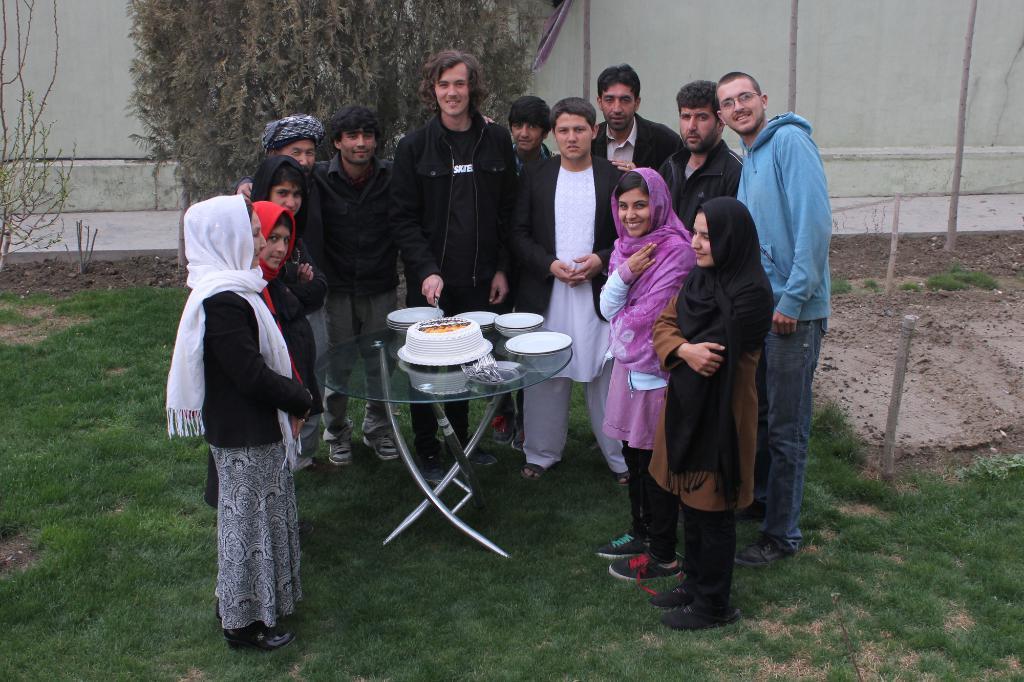How would you summarize this image in a sentence or two? These persons are standing. We can see cake,plates on the table. On the background we can see wall,trees. This is grass. 